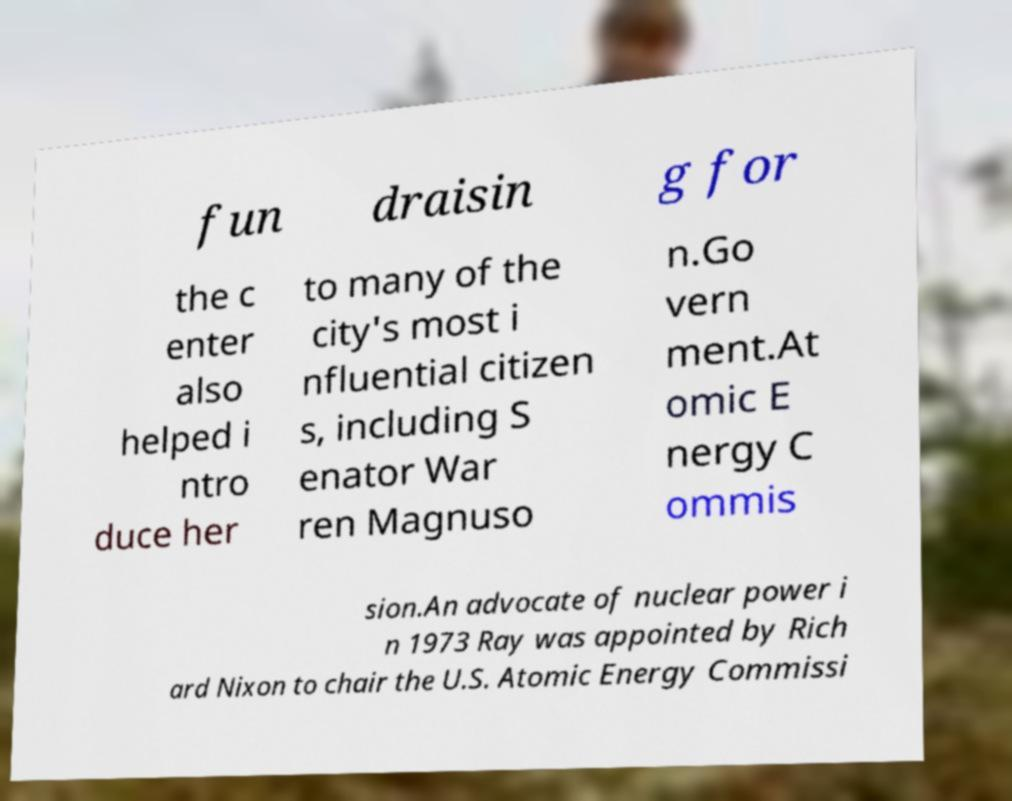Can you accurately transcribe the text from the provided image for me? fun draisin g for the c enter also helped i ntro duce her to many of the city's most i nfluential citizen s, including S enator War ren Magnuso n.Go vern ment.At omic E nergy C ommis sion.An advocate of nuclear power i n 1973 Ray was appointed by Rich ard Nixon to chair the U.S. Atomic Energy Commissi 